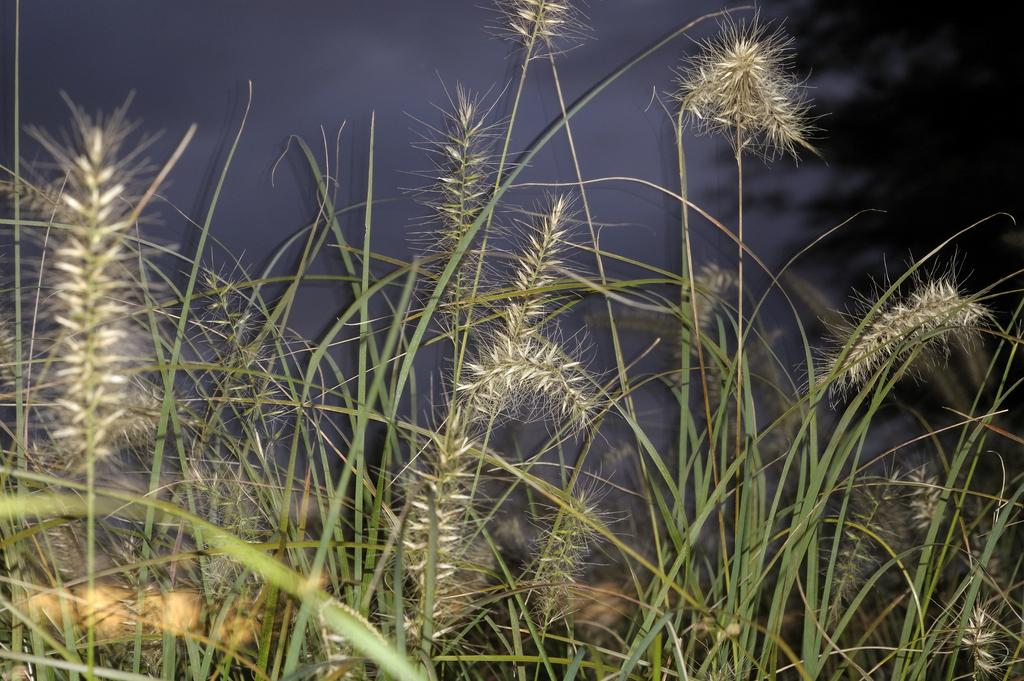What is located at the bottom of the image? There are plants at the bottom of the image. What can be seen at the top of the image? The sky is visible at the top of the image. What is in the background of the image? There is a tree in the background of the image. Can you tell me how many mothers are present in the image? There are no mothers present in the image; it features plants, the sky, and a tree. What type of mountain can be seen in the background of the image? There is no mountain present in the image; it features plants, the sky, and a tree. 